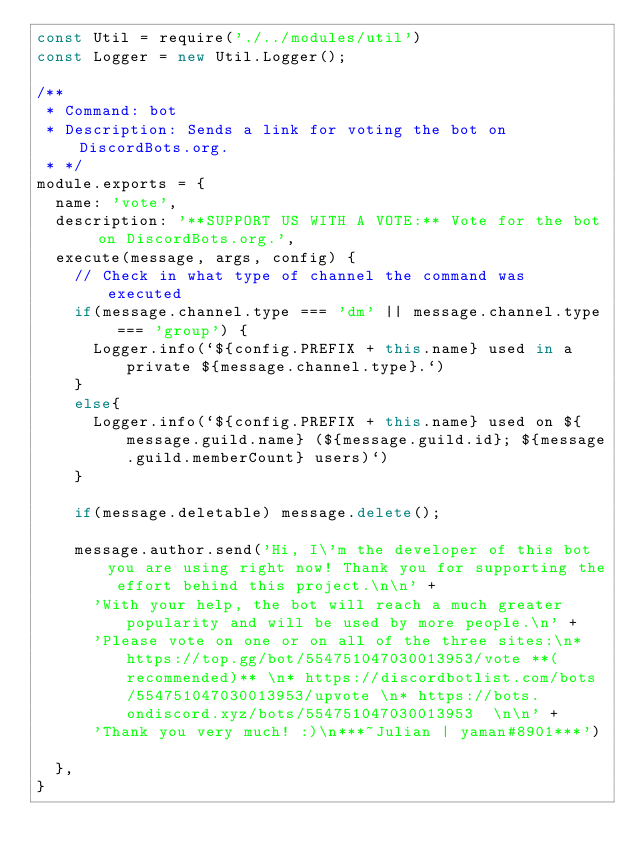<code> <loc_0><loc_0><loc_500><loc_500><_JavaScript_>const Util = require('./../modules/util')
const Logger = new Util.Logger();

/**
 * Command: bot
 * Description: Sends a link for voting the bot on DiscordBots.org.
 * */
module.exports = {
	name: 'vote',
	description: '**SUPPORT US WITH A VOTE:** Vote for the bot on DiscordBots.org.',
	execute(message, args, config) {
		// Check in what type of channel the command was executed
		if(message.channel.type === 'dm' || message.channel.type === 'group') {
			Logger.info(`${config.PREFIX + this.name} used in a private ${message.channel.type}.`)
		}
		else{
			Logger.info(`${config.PREFIX + this.name} used on ${message.guild.name} (${message.guild.id}; ${message.guild.memberCount} users)`)
		}

		if(message.deletable) message.delete();

		message.author.send('Hi, I\'m the developer of this bot you are using right now! Thank you for supporting the effort behind this project.\n\n' +
      'With your help, the bot will reach a much greater popularity and will be used by more people.\n' +
      'Please vote on one or on all of the three sites:\n* https://top.gg/bot/554751047030013953/vote **(recommended)** \n* https://discordbotlist.com/bots/554751047030013953/upvote \n* https://bots.ondiscord.xyz/bots/554751047030013953  \n\n' +
      'Thank you very much! :)\n***~Julian | yaman#8901***')

	},
}
</code> 